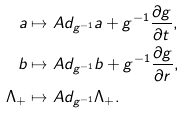Convert formula to latex. <formula><loc_0><loc_0><loc_500><loc_500>a & \mapsto A d _ { g ^ { - 1 } } a + g ^ { - 1 } \frac { \partial g } { \partial t } , \\ b & \mapsto A d _ { g ^ { - 1 } } b + g ^ { - 1 } \frac { \partial g } { \partial r } , \\ \Lambda _ { + } & \mapsto A d _ { g ^ { - 1 } } \Lambda _ { + } .</formula> 